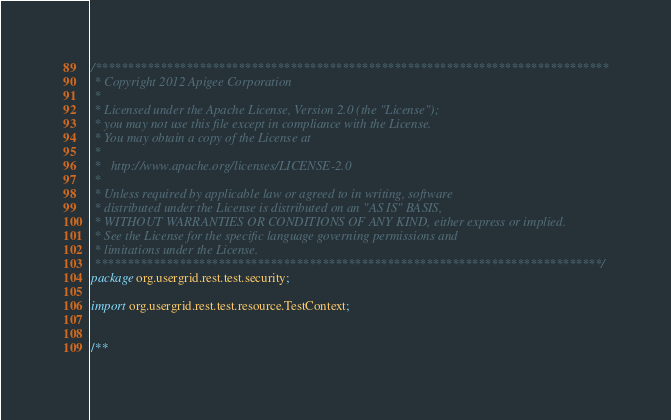Convert code to text. <code><loc_0><loc_0><loc_500><loc_500><_Java_>/*******************************************************************************
 * Copyright 2012 Apigee Corporation
 * 
 * Licensed under the Apache License, Version 2.0 (the "License");
 * you may not use this file except in compliance with the License.
 * You may obtain a copy of the License at
 * 
 *   http://www.apache.org/licenses/LICENSE-2.0
 * 
 * Unless required by applicable law or agreed to in writing, software
 * distributed under the License is distributed on an "AS IS" BASIS,
 * WITHOUT WARRANTIES OR CONDITIONS OF ANY KIND, either express or implied.
 * See the License for the specific language governing permissions and
 * limitations under the License.
 ******************************************************************************/
package org.usergrid.rest.test.security;

import org.usergrid.rest.test.resource.TestContext;


/**</code> 